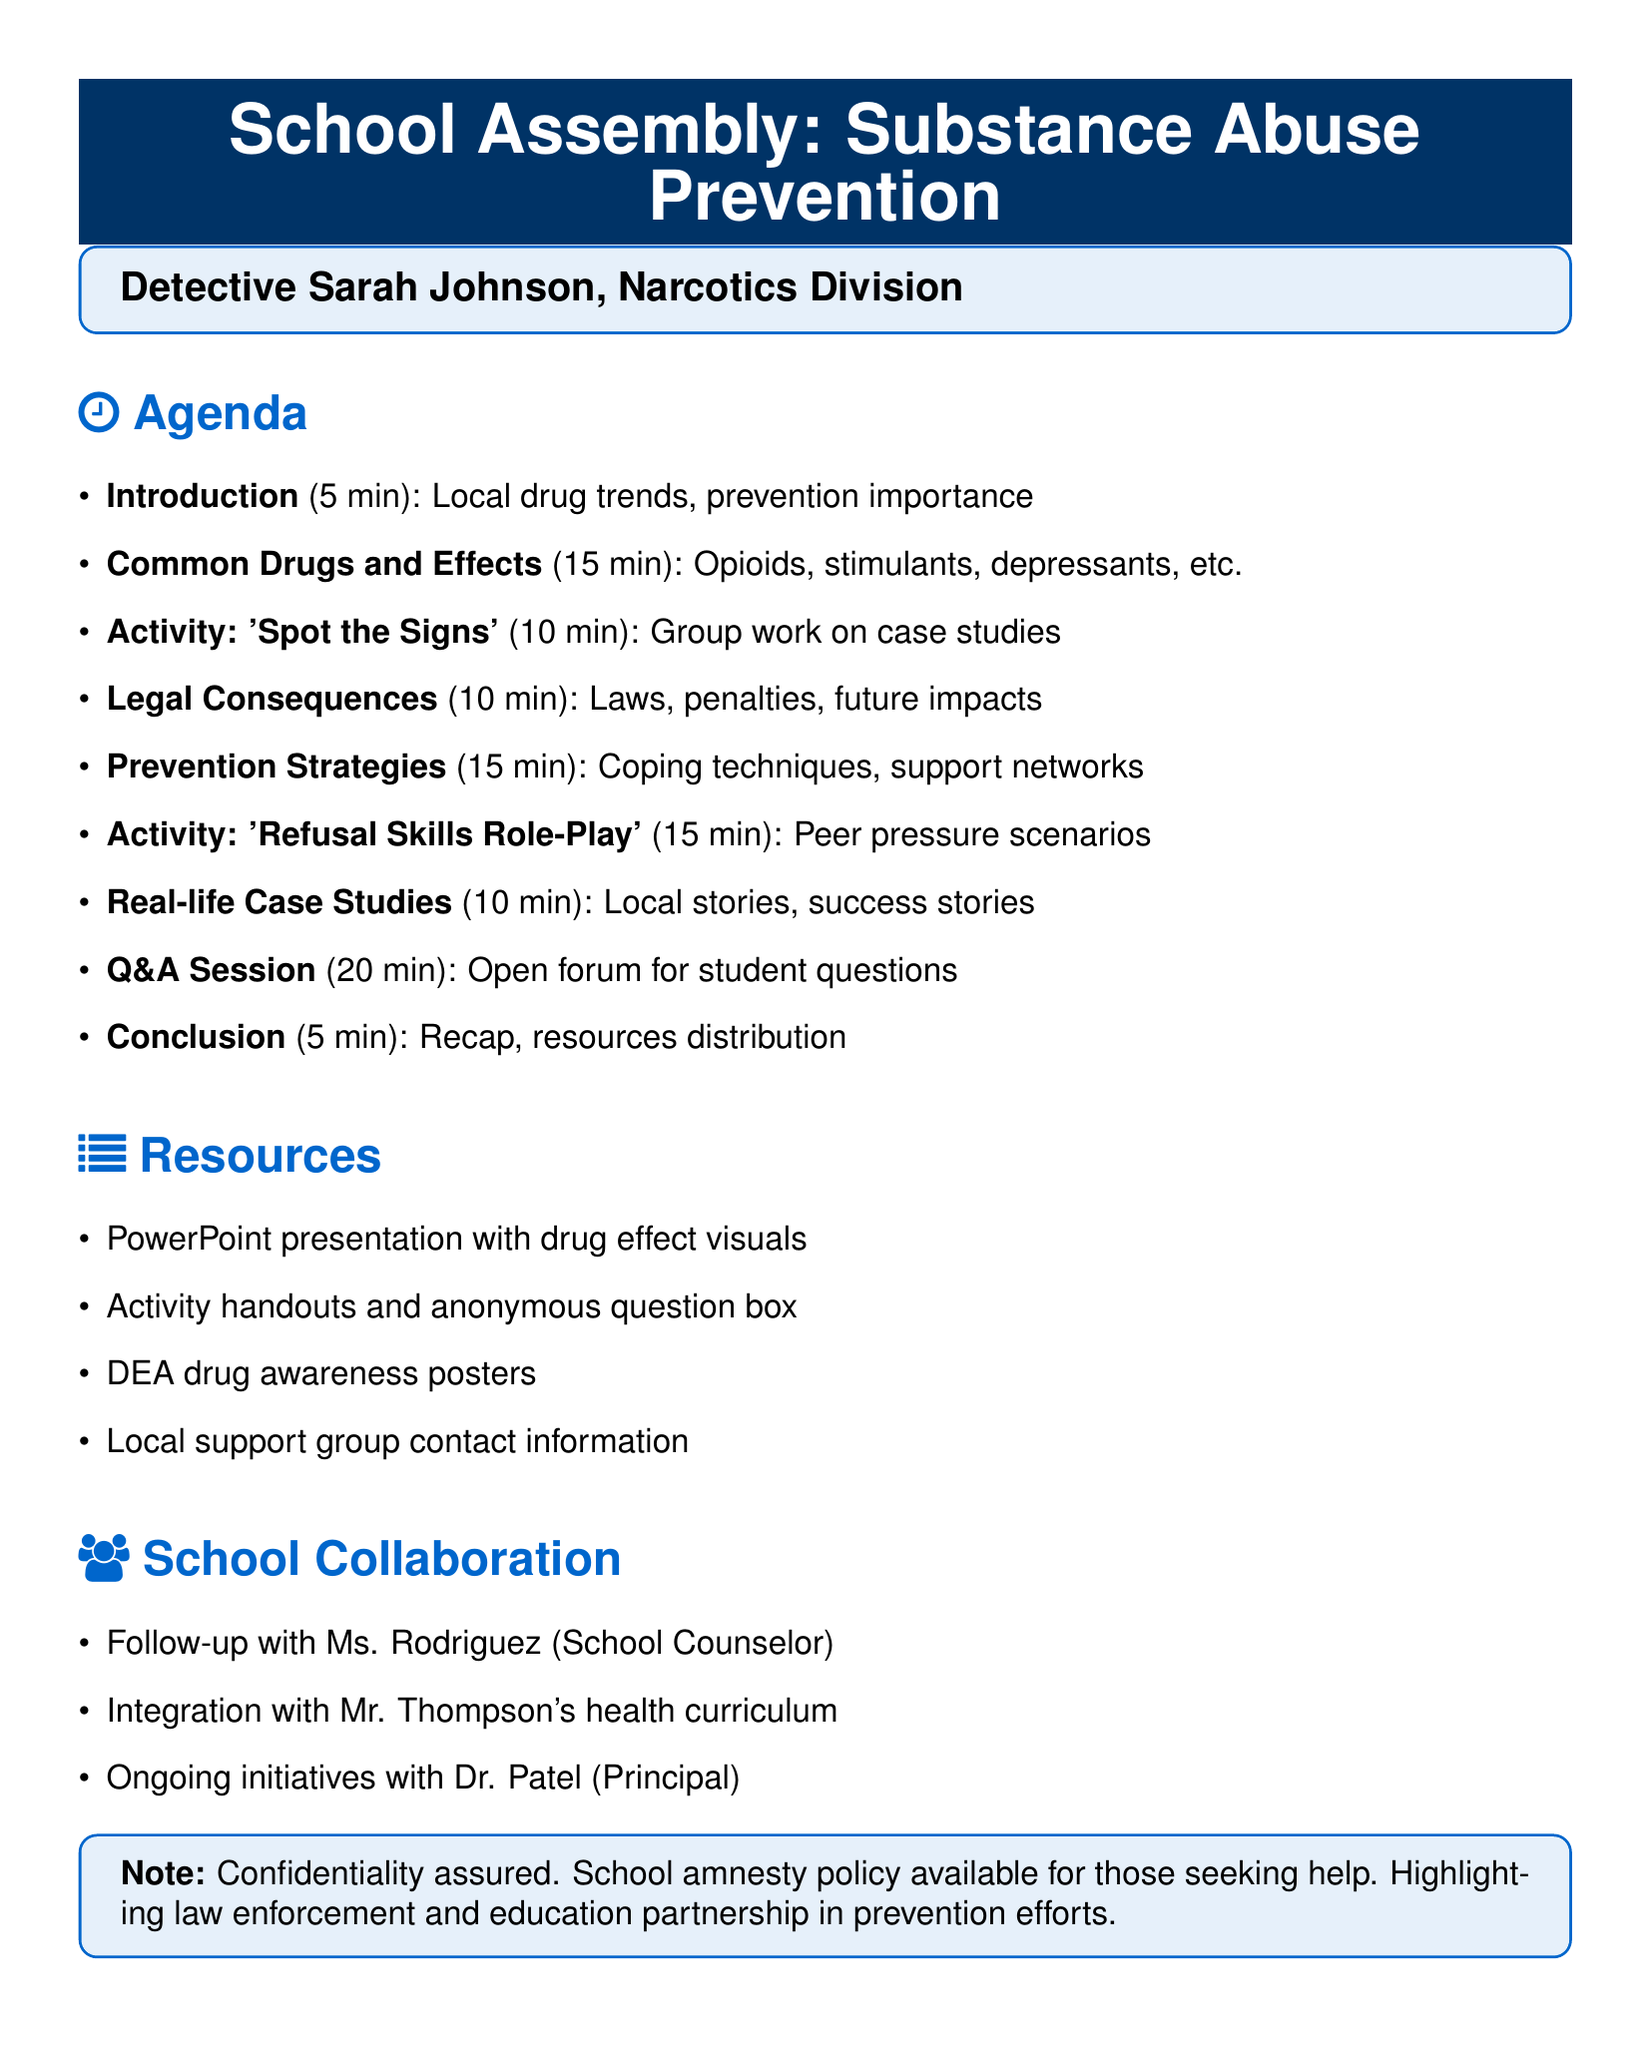What is the first section of the presentation? The first section is titled "Introduction" and outlines the initial topics to be covered.
Answer: Introduction How long is the Q&A session scheduled for? The agenda specifies that the Q&A session will last for 20 minutes.
Answer: 20 minutes What types of drugs are mentioned in the "Common Drugs and Their Effects" section? The section lists opioids, stimulants, depressants, hallucinogens, and cannabis as drug types covered.
Answer: Opioids, stimulants, depressants, hallucinogens, cannabis What interactive activity is included in the presentation? The document specifies two interactive activities: "Spot the Signs" and "Refusal Skills Role-Play."
Answer: Spot the Signs, Refusal Skills Role-Play Who is responsible for coordinating ongoing prevention initiatives at the school? The Principal, Dr. Patel, is noted as coordinating the ongoing prevention initiatives.
Answer: Dr. Patel What is one resource needed for the assembly? The agenda lists multiple resources, including a PowerPoint presentation with visuals of drug effects.
Answer: PowerPoint presentation with visuals of drug effects What is emphasized regarding the approach to confidentiality? The document highlights the importance of confidentiality and provides assurance to attendees about this.
Answer: Confidentiality assured How long is the "Prevention Strategies" section? The agenda indicates that the "Prevention Strategies" section will last for 15 minutes.
Answer: 15 minutes 